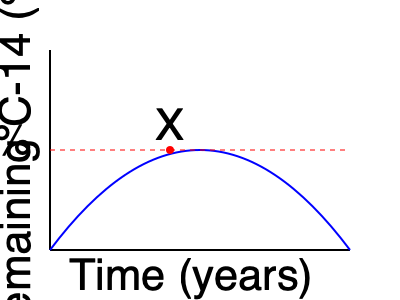Based on the radiocarbon decay curve shown in the graph, approximately how old is the cave art sample marked by point X? To determine the age of the cave art sample, we need to follow these steps:

1. Understand the graph:
   - The x-axis represents time (years)
   - The y-axis represents the percentage of remaining C-14
   - The blue curve represents the radiocarbon decay

2. Identify the half-life:
   - The red dashed line indicates 50% remaining C-14
   - Point X is located at the intersection of the decay curve and the 50% line

3. Recall the half-life of C-14:
   - The half-life of C-14 is approximately 5,730 years

4. Interpret the graph:
   - Since point X is at the 50% mark, it represents one half-life of C-14

5. Calculate the age:
   - The age of the sample is equal to one half-life of C-14
   - Age = 5,730 years

Therefore, the cave art sample marked by point X is approximately 5,730 years old.
Answer: 5,730 years 